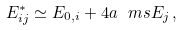Convert formula to latex. <formula><loc_0><loc_0><loc_500><loc_500>E ^ { * } _ { i j } \simeq E _ { 0 , i } + 4 a \ m s E _ { j } \, ,</formula> 